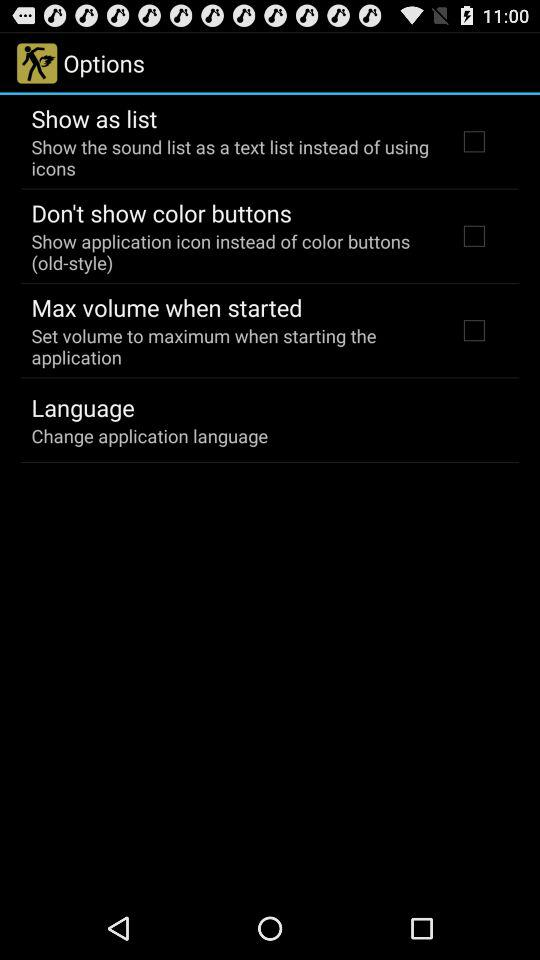What is the status of the "Max volume when started"? The status is "off". 